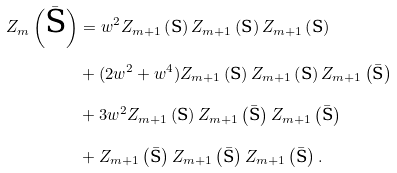Convert formula to latex. <formula><loc_0><loc_0><loc_500><loc_500>Z _ { m } \left ( \bar { \text {S} } \right ) & = w ^ { 2 } Z _ { m + 1 } \left ( \text {S} \right ) Z _ { m + 1 } \left ( \text {S} \right ) Z _ { m + 1 } \left ( \text {S} \right ) \\ & + ( 2 w ^ { 2 } + w ^ { 4 } ) Z _ { m + 1 } \left ( \text {S} \right ) Z _ { m + 1 } \left ( \text {S} \right ) Z _ { m + 1 } \left ( \bar { \text {S} } \right ) \\ & + 3 w ^ { 2 } Z _ { m + 1 } \left ( \text {S} \right ) Z _ { m + 1 } \left ( \bar { \text {S} } \right ) Z _ { m + 1 } \left ( \bar { \text {S} } \right ) \\ & + Z _ { m + 1 } \left ( \bar { \text {S} } \right ) Z _ { m + 1 } \left ( \bar { \text {S} } \right ) Z _ { m + 1 } \left ( \bar { \text {S} } \right ) .</formula> 